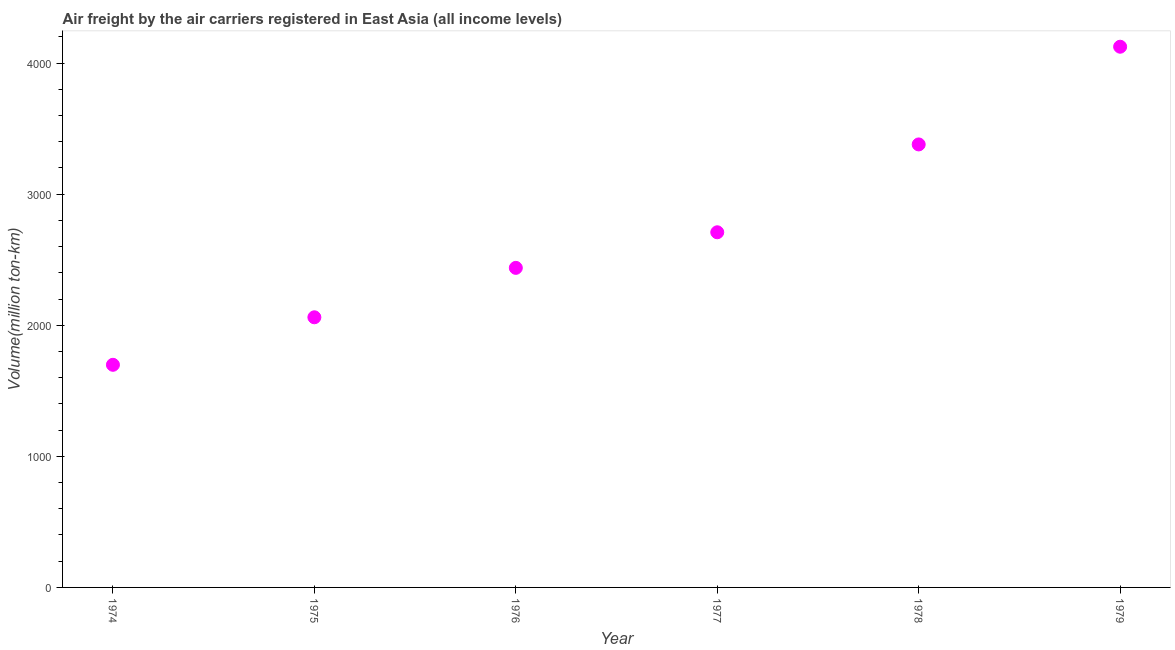What is the air freight in 1975?
Make the answer very short. 2060.5. Across all years, what is the maximum air freight?
Your answer should be very brief. 4124.3. Across all years, what is the minimum air freight?
Offer a terse response. 1698.1. In which year was the air freight maximum?
Make the answer very short. 1979. In which year was the air freight minimum?
Provide a succinct answer. 1974. What is the sum of the air freight?
Your response must be concise. 1.64e+04. What is the difference between the air freight in 1977 and 1978?
Ensure brevity in your answer.  -670.1. What is the average air freight per year?
Keep it short and to the point. 2734.75. What is the median air freight?
Offer a very short reply. 2573.25. In how many years, is the air freight greater than 800 million ton-km?
Your response must be concise. 6. Do a majority of the years between 1975 and 1974 (inclusive) have air freight greater than 1800 million ton-km?
Keep it short and to the point. No. What is the ratio of the air freight in 1974 to that in 1978?
Provide a short and direct response. 0.5. Is the air freight in 1974 less than that in 1977?
Your answer should be very brief. Yes. What is the difference between the highest and the second highest air freight?
Offer a very short reply. 745.2. Is the sum of the air freight in 1974 and 1976 greater than the maximum air freight across all years?
Your answer should be compact. Yes. What is the difference between the highest and the lowest air freight?
Offer a terse response. 2426.2. In how many years, is the air freight greater than the average air freight taken over all years?
Your answer should be very brief. 2. How many years are there in the graph?
Give a very brief answer. 6. What is the difference between two consecutive major ticks on the Y-axis?
Provide a succinct answer. 1000. Are the values on the major ticks of Y-axis written in scientific E-notation?
Your answer should be compact. No. Does the graph contain any zero values?
Your response must be concise. No. Does the graph contain grids?
Provide a succinct answer. No. What is the title of the graph?
Your response must be concise. Air freight by the air carriers registered in East Asia (all income levels). What is the label or title of the Y-axis?
Offer a terse response. Volume(million ton-km). What is the Volume(million ton-km) in 1974?
Ensure brevity in your answer.  1698.1. What is the Volume(million ton-km) in 1975?
Your answer should be compact. 2060.5. What is the Volume(million ton-km) in 1976?
Provide a succinct answer. 2437.5. What is the Volume(million ton-km) in 1977?
Your response must be concise. 2709. What is the Volume(million ton-km) in 1978?
Offer a terse response. 3379.1. What is the Volume(million ton-km) in 1979?
Keep it short and to the point. 4124.3. What is the difference between the Volume(million ton-km) in 1974 and 1975?
Your answer should be very brief. -362.4. What is the difference between the Volume(million ton-km) in 1974 and 1976?
Your response must be concise. -739.4. What is the difference between the Volume(million ton-km) in 1974 and 1977?
Your answer should be compact. -1010.9. What is the difference between the Volume(million ton-km) in 1974 and 1978?
Make the answer very short. -1681. What is the difference between the Volume(million ton-km) in 1974 and 1979?
Your answer should be very brief. -2426.2. What is the difference between the Volume(million ton-km) in 1975 and 1976?
Offer a terse response. -377. What is the difference between the Volume(million ton-km) in 1975 and 1977?
Provide a short and direct response. -648.5. What is the difference between the Volume(million ton-km) in 1975 and 1978?
Make the answer very short. -1318.6. What is the difference between the Volume(million ton-km) in 1975 and 1979?
Ensure brevity in your answer.  -2063.8. What is the difference between the Volume(million ton-km) in 1976 and 1977?
Your answer should be very brief. -271.5. What is the difference between the Volume(million ton-km) in 1976 and 1978?
Provide a succinct answer. -941.6. What is the difference between the Volume(million ton-km) in 1976 and 1979?
Give a very brief answer. -1686.8. What is the difference between the Volume(million ton-km) in 1977 and 1978?
Your answer should be very brief. -670.1. What is the difference between the Volume(million ton-km) in 1977 and 1979?
Provide a succinct answer. -1415.3. What is the difference between the Volume(million ton-km) in 1978 and 1979?
Offer a very short reply. -745.2. What is the ratio of the Volume(million ton-km) in 1974 to that in 1975?
Your answer should be compact. 0.82. What is the ratio of the Volume(million ton-km) in 1974 to that in 1976?
Provide a succinct answer. 0.7. What is the ratio of the Volume(million ton-km) in 1974 to that in 1977?
Ensure brevity in your answer.  0.63. What is the ratio of the Volume(million ton-km) in 1974 to that in 1978?
Ensure brevity in your answer.  0.5. What is the ratio of the Volume(million ton-km) in 1974 to that in 1979?
Provide a succinct answer. 0.41. What is the ratio of the Volume(million ton-km) in 1975 to that in 1976?
Make the answer very short. 0.84. What is the ratio of the Volume(million ton-km) in 1975 to that in 1977?
Provide a short and direct response. 0.76. What is the ratio of the Volume(million ton-km) in 1975 to that in 1978?
Your answer should be very brief. 0.61. What is the ratio of the Volume(million ton-km) in 1976 to that in 1977?
Offer a very short reply. 0.9. What is the ratio of the Volume(million ton-km) in 1976 to that in 1978?
Give a very brief answer. 0.72. What is the ratio of the Volume(million ton-km) in 1976 to that in 1979?
Your answer should be very brief. 0.59. What is the ratio of the Volume(million ton-km) in 1977 to that in 1978?
Offer a very short reply. 0.8. What is the ratio of the Volume(million ton-km) in 1977 to that in 1979?
Ensure brevity in your answer.  0.66. What is the ratio of the Volume(million ton-km) in 1978 to that in 1979?
Provide a short and direct response. 0.82. 